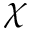Convert formula to latex. <formula><loc_0><loc_0><loc_500><loc_500>\chi</formula> 